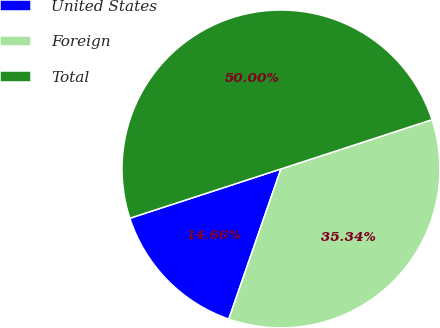<chart> <loc_0><loc_0><loc_500><loc_500><pie_chart><fcel>United States<fcel>Foreign<fcel>Total<nl><fcel>14.66%<fcel>35.34%<fcel>50.0%<nl></chart> 